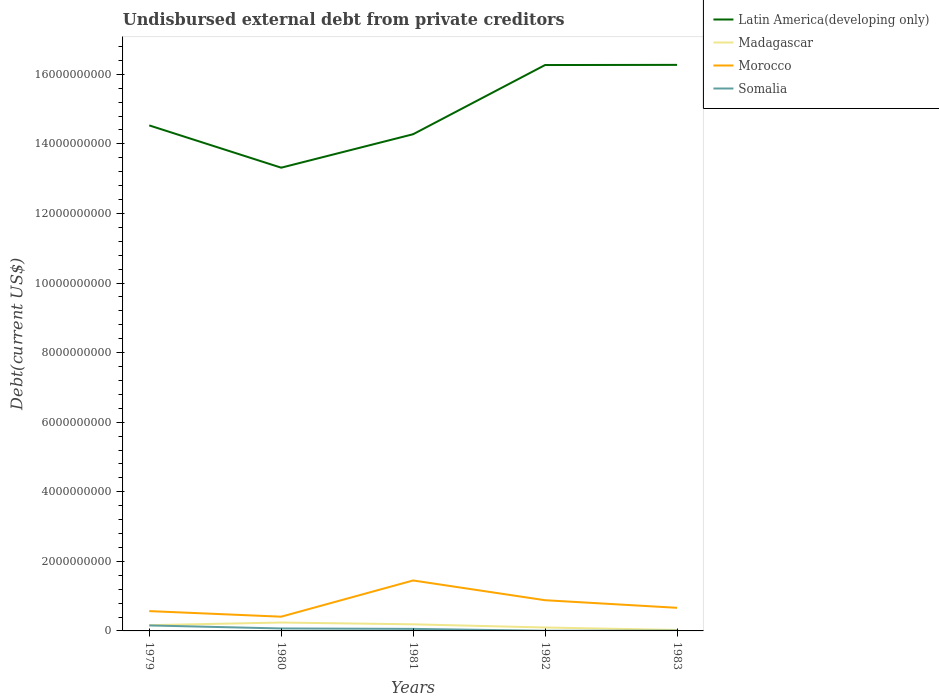Across all years, what is the maximum total debt in Somalia?
Keep it short and to the point. 5.57e+06. In which year was the total debt in Somalia maximum?
Make the answer very short. 1982. What is the total total debt in Latin America(developing only) in the graph?
Your response must be concise. -1.99e+09. What is the difference between the highest and the second highest total debt in Morocco?
Give a very brief answer. 1.04e+09. How many years are there in the graph?
Provide a short and direct response. 5. Are the values on the major ticks of Y-axis written in scientific E-notation?
Offer a very short reply. No. Does the graph contain grids?
Make the answer very short. No. Where does the legend appear in the graph?
Provide a short and direct response. Top right. How many legend labels are there?
Make the answer very short. 4. How are the legend labels stacked?
Your response must be concise. Vertical. What is the title of the graph?
Ensure brevity in your answer.  Undisbursed external debt from private creditors. What is the label or title of the Y-axis?
Provide a succinct answer. Debt(current US$). What is the Debt(current US$) of Latin America(developing only) in 1979?
Make the answer very short. 1.45e+1. What is the Debt(current US$) of Madagascar in 1979?
Offer a terse response. 1.65e+08. What is the Debt(current US$) of Morocco in 1979?
Your answer should be compact. 5.70e+08. What is the Debt(current US$) of Somalia in 1979?
Provide a succinct answer. 1.58e+08. What is the Debt(current US$) in Latin America(developing only) in 1980?
Provide a succinct answer. 1.33e+1. What is the Debt(current US$) of Madagascar in 1980?
Provide a short and direct response. 2.41e+08. What is the Debt(current US$) in Morocco in 1980?
Your response must be concise. 4.09e+08. What is the Debt(current US$) of Somalia in 1980?
Ensure brevity in your answer.  7.03e+07. What is the Debt(current US$) of Latin America(developing only) in 1981?
Ensure brevity in your answer.  1.43e+1. What is the Debt(current US$) in Madagascar in 1981?
Provide a short and direct response. 1.90e+08. What is the Debt(current US$) in Morocco in 1981?
Provide a short and direct response. 1.45e+09. What is the Debt(current US$) of Somalia in 1981?
Your response must be concise. 5.82e+07. What is the Debt(current US$) in Latin America(developing only) in 1982?
Keep it short and to the point. 1.63e+1. What is the Debt(current US$) of Madagascar in 1982?
Give a very brief answer. 9.86e+07. What is the Debt(current US$) of Morocco in 1982?
Your answer should be compact. 8.82e+08. What is the Debt(current US$) in Somalia in 1982?
Your answer should be compact. 5.57e+06. What is the Debt(current US$) in Latin America(developing only) in 1983?
Give a very brief answer. 1.63e+1. What is the Debt(current US$) in Madagascar in 1983?
Keep it short and to the point. 2.73e+07. What is the Debt(current US$) in Morocco in 1983?
Offer a very short reply. 6.64e+08. What is the Debt(current US$) of Somalia in 1983?
Keep it short and to the point. 8.74e+06. Across all years, what is the maximum Debt(current US$) in Latin America(developing only)?
Make the answer very short. 1.63e+1. Across all years, what is the maximum Debt(current US$) of Madagascar?
Make the answer very short. 2.41e+08. Across all years, what is the maximum Debt(current US$) in Morocco?
Provide a short and direct response. 1.45e+09. Across all years, what is the maximum Debt(current US$) in Somalia?
Give a very brief answer. 1.58e+08. Across all years, what is the minimum Debt(current US$) of Latin America(developing only)?
Keep it short and to the point. 1.33e+1. Across all years, what is the minimum Debt(current US$) in Madagascar?
Offer a very short reply. 2.73e+07. Across all years, what is the minimum Debt(current US$) in Morocco?
Your response must be concise. 4.09e+08. Across all years, what is the minimum Debt(current US$) in Somalia?
Your answer should be compact. 5.57e+06. What is the total Debt(current US$) in Latin America(developing only) in the graph?
Offer a very short reply. 7.47e+1. What is the total Debt(current US$) of Madagascar in the graph?
Your answer should be compact. 7.22e+08. What is the total Debt(current US$) in Morocco in the graph?
Ensure brevity in your answer.  3.98e+09. What is the total Debt(current US$) of Somalia in the graph?
Offer a terse response. 3.00e+08. What is the difference between the Debt(current US$) in Latin America(developing only) in 1979 and that in 1980?
Your answer should be very brief. 1.22e+09. What is the difference between the Debt(current US$) in Madagascar in 1979 and that in 1980?
Ensure brevity in your answer.  -7.65e+07. What is the difference between the Debt(current US$) of Morocco in 1979 and that in 1980?
Give a very brief answer. 1.60e+08. What is the difference between the Debt(current US$) of Somalia in 1979 and that in 1980?
Provide a short and direct response. 8.73e+07. What is the difference between the Debt(current US$) of Latin America(developing only) in 1979 and that in 1981?
Give a very brief answer. 2.53e+08. What is the difference between the Debt(current US$) in Madagascar in 1979 and that in 1981?
Your answer should be compact. -2.54e+07. What is the difference between the Debt(current US$) in Morocco in 1979 and that in 1981?
Ensure brevity in your answer.  -8.81e+08. What is the difference between the Debt(current US$) in Somalia in 1979 and that in 1981?
Keep it short and to the point. 9.94e+07. What is the difference between the Debt(current US$) of Latin America(developing only) in 1979 and that in 1982?
Provide a succinct answer. -1.74e+09. What is the difference between the Debt(current US$) in Madagascar in 1979 and that in 1982?
Your answer should be very brief. 6.61e+07. What is the difference between the Debt(current US$) of Morocco in 1979 and that in 1982?
Your answer should be compact. -3.13e+08. What is the difference between the Debt(current US$) in Somalia in 1979 and that in 1982?
Give a very brief answer. 1.52e+08. What is the difference between the Debt(current US$) of Latin America(developing only) in 1979 and that in 1983?
Your response must be concise. -1.74e+09. What is the difference between the Debt(current US$) of Madagascar in 1979 and that in 1983?
Your answer should be compact. 1.37e+08. What is the difference between the Debt(current US$) in Morocco in 1979 and that in 1983?
Your answer should be very brief. -9.48e+07. What is the difference between the Debt(current US$) in Somalia in 1979 and that in 1983?
Make the answer very short. 1.49e+08. What is the difference between the Debt(current US$) in Latin America(developing only) in 1980 and that in 1981?
Keep it short and to the point. -9.62e+08. What is the difference between the Debt(current US$) of Madagascar in 1980 and that in 1981?
Offer a very short reply. 5.11e+07. What is the difference between the Debt(current US$) of Morocco in 1980 and that in 1981?
Make the answer very short. -1.04e+09. What is the difference between the Debt(current US$) of Somalia in 1980 and that in 1981?
Your answer should be very brief. 1.21e+07. What is the difference between the Debt(current US$) in Latin America(developing only) in 1980 and that in 1982?
Provide a succinct answer. -2.95e+09. What is the difference between the Debt(current US$) of Madagascar in 1980 and that in 1982?
Your response must be concise. 1.43e+08. What is the difference between the Debt(current US$) in Morocco in 1980 and that in 1982?
Offer a terse response. -4.73e+08. What is the difference between the Debt(current US$) of Somalia in 1980 and that in 1982?
Your answer should be compact. 6.48e+07. What is the difference between the Debt(current US$) of Latin America(developing only) in 1980 and that in 1983?
Your answer should be compact. -2.96e+09. What is the difference between the Debt(current US$) in Madagascar in 1980 and that in 1983?
Give a very brief answer. 2.14e+08. What is the difference between the Debt(current US$) of Morocco in 1980 and that in 1983?
Offer a terse response. -2.55e+08. What is the difference between the Debt(current US$) in Somalia in 1980 and that in 1983?
Offer a terse response. 6.16e+07. What is the difference between the Debt(current US$) in Latin America(developing only) in 1981 and that in 1982?
Ensure brevity in your answer.  -1.99e+09. What is the difference between the Debt(current US$) in Madagascar in 1981 and that in 1982?
Your answer should be compact. 9.15e+07. What is the difference between the Debt(current US$) in Morocco in 1981 and that in 1982?
Keep it short and to the point. 5.68e+08. What is the difference between the Debt(current US$) of Somalia in 1981 and that in 1982?
Your response must be concise. 5.26e+07. What is the difference between the Debt(current US$) in Latin America(developing only) in 1981 and that in 1983?
Ensure brevity in your answer.  -1.99e+09. What is the difference between the Debt(current US$) in Madagascar in 1981 and that in 1983?
Offer a terse response. 1.63e+08. What is the difference between the Debt(current US$) of Morocco in 1981 and that in 1983?
Offer a very short reply. 7.86e+08. What is the difference between the Debt(current US$) in Somalia in 1981 and that in 1983?
Ensure brevity in your answer.  4.95e+07. What is the difference between the Debt(current US$) in Latin America(developing only) in 1982 and that in 1983?
Ensure brevity in your answer.  -4.65e+06. What is the difference between the Debt(current US$) in Madagascar in 1982 and that in 1983?
Offer a very short reply. 7.13e+07. What is the difference between the Debt(current US$) of Morocco in 1982 and that in 1983?
Your answer should be very brief. 2.18e+08. What is the difference between the Debt(current US$) of Somalia in 1982 and that in 1983?
Give a very brief answer. -3.17e+06. What is the difference between the Debt(current US$) of Latin America(developing only) in 1979 and the Debt(current US$) of Madagascar in 1980?
Your answer should be compact. 1.43e+1. What is the difference between the Debt(current US$) of Latin America(developing only) in 1979 and the Debt(current US$) of Morocco in 1980?
Provide a short and direct response. 1.41e+1. What is the difference between the Debt(current US$) of Latin America(developing only) in 1979 and the Debt(current US$) of Somalia in 1980?
Offer a terse response. 1.45e+1. What is the difference between the Debt(current US$) in Madagascar in 1979 and the Debt(current US$) in Morocco in 1980?
Provide a succinct answer. -2.45e+08. What is the difference between the Debt(current US$) in Madagascar in 1979 and the Debt(current US$) in Somalia in 1980?
Ensure brevity in your answer.  9.43e+07. What is the difference between the Debt(current US$) in Morocco in 1979 and the Debt(current US$) in Somalia in 1980?
Your answer should be compact. 4.99e+08. What is the difference between the Debt(current US$) in Latin America(developing only) in 1979 and the Debt(current US$) in Madagascar in 1981?
Ensure brevity in your answer.  1.43e+1. What is the difference between the Debt(current US$) of Latin America(developing only) in 1979 and the Debt(current US$) of Morocco in 1981?
Offer a very short reply. 1.31e+1. What is the difference between the Debt(current US$) in Latin America(developing only) in 1979 and the Debt(current US$) in Somalia in 1981?
Your answer should be very brief. 1.45e+1. What is the difference between the Debt(current US$) of Madagascar in 1979 and the Debt(current US$) of Morocco in 1981?
Give a very brief answer. -1.29e+09. What is the difference between the Debt(current US$) in Madagascar in 1979 and the Debt(current US$) in Somalia in 1981?
Your answer should be compact. 1.06e+08. What is the difference between the Debt(current US$) in Morocco in 1979 and the Debt(current US$) in Somalia in 1981?
Provide a short and direct response. 5.11e+08. What is the difference between the Debt(current US$) of Latin America(developing only) in 1979 and the Debt(current US$) of Madagascar in 1982?
Offer a terse response. 1.44e+1. What is the difference between the Debt(current US$) in Latin America(developing only) in 1979 and the Debt(current US$) in Morocco in 1982?
Keep it short and to the point. 1.36e+1. What is the difference between the Debt(current US$) of Latin America(developing only) in 1979 and the Debt(current US$) of Somalia in 1982?
Provide a short and direct response. 1.45e+1. What is the difference between the Debt(current US$) of Madagascar in 1979 and the Debt(current US$) of Morocco in 1982?
Your answer should be very brief. -7.18e+08. What is the difference between the Debt(current US$) of Madagascar in 1979 and the Debt(current US$) of Somalia in 1982?
Give a very brief answer. 1.59e+08. What is the difference between the Debt(current US$) in Morocco in 1979 and the Debt(current US$) in Somalia in 1982?
Your answer should be compact. 5.64e+08. What is the difference between the Debt(current US$) in Latin America(developing only) in 1979 and the Debt(current US$) in Madagascar in 1983?
Offer a terse response. 1.45e+1. What is the difference between the Debt(current US$) in Latin America(developing only) in 1979 and the Debt(current US$) in Morocco in 1983?
Make the answer very short. 1.39e+1. What is the difference between the Debt(current US$) in Latin America(developing only) in 1979 and the Debt(current US$) in Somalia in 1983?
Your response must be concise. 1.45e+1. What is the difference between the Debt(current US$) in Madagascar in 1979 and the Debt(current US$) in Morocco in 1983?
Offer a very short reply. -5.00e+08. What is the difference between the Debt(current US$) in Madagascar in 1979 and the Debt(current US$) in Somalia in 1983?
Your response must be concise. 1.56e+08. What is the difference between the Debt(current US$) of Morocco in 1979 and the Debt(current US$) of Somalia in 1983?
Your answer should be very brief. 5.61e+08. What is the difference between the Debt(current US$) of Latin America(developing only) in 1980 and the Debt(current US$) of Madagascar in 1981?
Offer a very short reply. 1.31e+1. What is the difference between the Debt(current US$) of Latin America(developing only) in 1980 and the Debt(current US$) of Morocco in 1981?
Keep it short and to the point. 1.19e+1. What is the difference between the Debt(current US$) of Latin America(developing only) in 1980 and the Debt(current US$) of Somalia in 1981?
Ensure brevity in your answer.  1.33e+1. What is the difference between the Debt(current US$) of Madagascar in 1980 and the Debt(current US$) of Morocco in 1981?
Your response must be concise. -1.21e+09. What is the difference between the Debt(current US$) of Madagascar in 1980 and the Debt(current US$) of Somalia in 1981?
Provide a succinct answer. 1.83e+08. What is the difference between the Debt(current US$) of Morocco in 1980 and the Debt(current US$) of Somalia in 1981?
Your answer should be compact. 3.51e+08. What is the difference between the Debt(current US$) in Latin America(developing only) in 1980 and the Debt(current US$) in Madagascar in 1982?
Make the answer very short. 1.32e+1. What is the difference between the Debt(current US$) in Latin America(developing only) in 1980 and the Debt(current US$) in Morocco in 1982?
Your response must be concise. 1.24e+1. What is the difference between the Debt(current US$) of Latin America(developing only) in 1980 and the Debt(current US$) of Somalia in 1982?
Offer a terse response. 1.33e+1. What is the difference between the Debt(current US$) in Madagascar in 1980 and the Debt(current US$) in Morocco in 1982?
Ensure brevity in your answer.  -6.41e+08. What is the difference between the Debt(current US$) of Madagascar in 1980 and the Debt(current US$) of Somalia in 1982?
Your answer should be very brief. 2.36e+08. What is the difference between the Debt(current US$) of Morocco in 1980 and the Debt(current US$) of Somalia in 1982?
Provide a short and direct response. 4.04e+08. What is the difference between the Debt(current US$) of Latin America(developing only) in 1980 and the Debt(current US$) of Madagascar in 1983?
Offer a very short reply. 1.33e+1. What is the difference between the Debt(current US$) of Latin America(developing only) in 1980 and the Debt(current US$) of Morocco in 1983?
Make the answer very short. 1.27e+1. What is the difference between the Debt(current US$) in Latin America(developing only) in 1980 and the Debt(current US$) in Somalia in 1983?
Offer a terse response. 1.33e+1. What is the difference between the Debt(current US$) in Madagascar in 1980 and the Debt(current US$) in Morocco in 1983?
Provide a succinct answer. -4.23e+08. What is the difference between the Debt(current US$) in Madagascar in 1980 and the Debt(current US$) in Somalia in 1983?
Give a very brief answer. 2.32e+08. What is the difference between the Debt(current US$) in Morocco in 1980 and the Debt(current US$) in Somalia in 1983?
Your answer should be compact. 4.01e+08. What is the difference between the Debt(current US$) in Latin America(developing only) in 1981 and the Debt(current US$) in Madagascar in 1982?
Offer a very short reply. 1.42e+1. What is the difference between the Debt(current US$) in Latin America(developing only) in 1981 and the Debt(current US$) in Morocco in 1982?
Your answer should be very brief. 1.34e+1. What is the difference between the Debt(current US$) in Latin America(developing only) in 1981 and the Debt(current US$) in Somalia in 1982?
Provide a short and direct response. 1.43e+1. What is the difference between the Debt(current US$) in Madagascar in 1981 and the Debt(current US$) in Morocco in 1982?
Offer a terse response. -6.92e+08. What is the difference between the Debt(current US$) of Madagascar in 1981 and the Debt(current US$) of Somalia in 1982?
Offer a terse response. 1.85e+08. What is the difference between the Debt(current US$) of Morocco in 1981 and the Debt(current US$) of Somalia in 1982?
Make the answer very short. 1.44e+09. What is the difference between the Debt(current US$) of Latin America(developing only) in 1981 and the Debt(current US$) of Madagascar in 1983?
Ensure brevity in your answer.  1.43e+1. What is the difference between the Debt(current US$) of Latin America(developing only) in 1981 and the Debt(current US$) of Morocco in 1983?
Provide a succinct answer. 1.36e+1. What is the difference between the Debt(current US$) in Latin America(developing only) in 1981 and the Debt(current US$) in Somalia in 1983?
Keep it short and to the point. 1.43e+1. What is the difference between the Debt(current US$) in Madagascar in 1981 and the Debt(current US$) in Morocco in 1983?
Provide a succinct answer. -4.74e+08. What is the difference between the Debt(current US$) of Madagascar in 1981 and the Debt(current US$) of Somalia in 1983?
Offer a very short reply. 1.81e+08. What is the difference between the Debt(current US$) of Morocco in 1981 and the Debt(current US$) of Somalia in 1983?
Your answer should be compact. 1.44e+09. What is the difference between the Debt(current US$) of Latin America(developing only) in 1982 and the Debt(current US$) of Madagascar in 1983?
Keep it short and to the point. 1.62e+1. What is the difference between the Debt(current US$) of Latin America(developing only) in 1982 and the Debt(current US$) of Morocco in 1983?
Offer a very short reply. 1.56e+1. What is the difference between the Debt(current US$) in Latin America(developing only) in 1982 and the Debt(current US$) in Somalia in 1983?
Your response must be concise. 1.63e+1. What is the difference between the Debt(current US$) of Madagascar in 1982 and the Debt(current US$) of Morocco in 1983?
Ensure brevity in your answer.  -5.66e+08. What is the difference between the Debt(current US$) in Madagascar in 1982 and the Debt(current US$) in Somalia in 1983?
Make the answer very short. 8.98e+07. What is the difference between the Debt(current US$) in Morocco in 1982 and the Debt(current US$) in Somalia in 1983?
Your response must be concise. 8.74e+08. What is the average Debt(current US$) of Latin America(developing only) per year?
Your response must be concise. 1.49e+1. What is the average Debt(current US$) in Madagascar per year?
Ensure brevity in your answer.  1.44e+08. What is the average Debt(current US$) of Morocco per year?
Your answer should be very brief. 7.95e+08. What is the average Debt(current US$) of Somalia per year?
Provide a succinct answer. 6.01e+07. In the year 1979, what is the difference between the Debt(current US$) in Latin America(developing only) and Debt(current US$) in Madagascar?
Your answer should be very brief. 1.44e+1. In the year 1979, what is the difference between the Debt(current US$) in Latin America(developing only) and Debt(current US$) in Morocco?
Give a very brief answer. 1.40e+1. In the year 1979, what is the difference between the Debt(current US$) in Latin America(developing only) and Debt(current US$) in Somalia?
Keep it short and to the point. 1.44e+1. In the year 1979, what is the difference between the Debt(current US$) in Madagascar and Debt(current US$) in Morocco?
Provide a succinct answer. -4.05e+08. In the year 1979, what is the difference between the Debt(current US$) in Madagascar and Debt(current US$) in Somalia?
Ensure brevity in your answer.  7.07e+06. In the year 1979, what is the difference between the Debt(current US$) in Morocco and Debt(current US$) in Somalia?
Ensure brevity in your answer.  4.12e+08. In the year 1980, what is the difference between the Debt(current US$) of Latin America(developing only) and Debt(current US$) of Madagascar?
Your answer should be very brief. 1.31e+1. In the year 1980, what is the difference between the Debt(current US$) of Latin America(developing only) and Debt(current US$) of Morocco?
Your answer should be compact. 1.29e+1. In the year 1980, what is the difference between the Debt(current US$) in Latin America(developing only) and Debt(current US$) in Somalia?
Ensure brevity in your answer.  1.32e+1. In the year 1980, what is the difference between the Debt(current US$) of Madagascar and Debt(current US$) of Morocco?
Give a very brief answer. -1.68e+08. In the year 1980, what is the difference between the Debt(current US$) of Madagascar and Debt(current US$) of Somalia?
Your response must be concise. 1.71e+08. In the year 1980, what is the difference between the Debt(current US$) of Morocco and Debt(current US$) of Somalia?
Ensure brevity in your answer.  3.39e+08. In the year 1981, what is the difference between the Debt(current US$) of Latin America(developing only) and Debt(current US$) of Madagascar?
Make the answer very short. 1.41e+1. In the year 1981, what is the difference between the Debt(current US$) of Latin America(developing only) and Debt(current US$) of Morocco?
Offer a terse response. 1.28e+1. In the year 1981, what is the difference between the Debt(current US$) in Latin America(developing only) and Debt(current US$) in Somalia?
Offer a very short reply. 1.42e+1. In the year 1981, what is the difference between the Debt(current US$) of Madagascar and Debt(current US$) of Morocco?
Your response must be concise. -1.26e+09. In the year 1981, what is the difference between the Debt(current US$) of Madagascar and Debt(current US$) of Somalia?
Ensure brevity in your answer.  1.32e+08. In the year 1981, what is the difference between the Debt(current US$) in Morocco and Debt(current US$) in Somalia?
Provide a short and direct response. 1.39e+09. In the year 1982, what is the difference between the Debt(current US$) of Latin America(developing only) and Debt(current US$) of Madagascar?
Your answer should be very brief. 1.62e+1. In the year 1982, what is the difference between the Debt(current US$) of Latin America(developing only) and Debt(current US$) of Morocco?
Offer a terse response. 1.54e+1. In the year 1982, what is the difference between the Debt(current US$) of Latin America(developing only) and Debt(current US$) of Somalia?
Your response must be concise. 1.63e+1. In the year 1982, what is the difference between the Debt(current US$) of Madagascar and Debt(current US$) of Morocco?
Make the answer very short. -7.84e+08. In the year 1982, what is the difference between the Debt(current US$) of Madagascar and Debt(current US$) of Somalia?
Offer a very short reply. 9.30e+07. In the year 1982, what is the difference between the Debt(current US$) of Morocco and Debt(current US$) of Somalia?
Your answer should be very brief. 8.77e+08. In the year 1983, what is the difference between the Debt(current US$) of Latin America(developing only) and Debt(current US$) of Madagascar?
Your response must be concise. 1.62e+1. In the year 1983, what is the difference between the Debt(current US$) in Latin America(developing only) and Debt(current US$) in Morocco?
Provide a short and direct response. 1.56e+1. In the year 1983, what is the difference between the Debt(current US$) of Latin America(developing only) and Debt(current US$) of Somalia?
Offer a very short reply. 1.63e+1. In the year 1983, what is the difference between the Debt(current US$) in Madagascar and Debt(current US$) in Morocco?
Keep it short and to the point. -6.37e+08. In the year 1983, what is the difference between the Debt(current US$) of Madagascar and Debt(current US$) of Somalia?
Your response must be concise. 1.85e+07. In the year 1983, what is the difference between the Debt(current US$) of Morocco and Debt(current US$) of Somalia?
Provide a succinct answer. 6.56e+08. What is the ratio of the Debt(current US$) in Latin America(developing only) in 1979 to that in 1980?
Give a very brief answer. 1.09. What is the ratio of the Debt(current US$) in Madagascar in 1979 to that in 1980?
Your answer should be very brief. 0.68. What is the ratio of the Debt(current US$) of Morocco in 1979 to that in 1980?
Make the answer very short. 1.39. What is the ratio of the Debt(current US$) in Somalia in 1979 to that in 1980?
Your response must be concise. 2.24. What is the ratio of the Debt(current US$) of Latin America(developing only) in 1979 to that in 1981?
Your answer should be very brief. 1.02. What is the ratio of the Debt(current US$) of Madagascar in 1979 to that in 1981?
Offer a terse response. 0.87. What is the ratio of the Debt(current US$) of Morocco in 1979 to that in 1981?
Ensure brevity in your answer.  0.39. What is the ratio of the Debt(current US$) in Somalia in 1979 to that in 1981?
Give a very brief answer. 2.71. What is the ratio of the Debt(current US$) in Latin America(developing only) in 1979 to that in 1982?
Provide a succinct answer. 0.89. What is the ratio of the Debt(current US$) in Madagascar in 1979 to that in 1982?
Give a very brief answer. 1.67. What is the ratio of the Debt(current US$) in Morocco in 1979 to that in 1982?
Provide a succinct answer. 0.65. What is the ratio of the Debt(current US$) in Somalia in 1979 to that in 1982?
Your answer should be very brief. 28.31. What is the ratio of the Debt(current US$) in Latin America(developing only) in 1979 to that in 1983?
Offer a very short reply. 0.89. What is the ratio of the Debt(current US$) of Madagascar in 1979 to that in 1983?
Ensure brevity in your answer.  6.04. What is the ratio of the Debt(current US$) in Morocco in 1979 to that in 1983?
Offer a terse response. 0.86. What is the ratio of the Debt(current US$) in Somalia in 1979 to that in 1983?
Your answer should be very brief. 18.03. What is the ratio of the Debt(current US$) of Latin America(developing only) in 1980 to that in 1981?
Make the answer very short. 0.93. What is the ratio of the Debt(current US$) of Madagascar in 1980 to that in 1981?
Your response must be concise. 1.27. What is the ratio of the Debt(current US$) in Morocco in 1980 to that in 1981?
Your answer should be compact. 0.28. What is the ratio of the Debt(current US$) in Somalia in 1980 to that in 1981?
Keep it short and to the point. 1.21. What is the ratio of the Debt(current US$) in Latin America(developing only) in 1980 to that in 1982?
Offer a terse response. 0.82. What is the ratio of the Debt(current US$) in Madagascar in 1980 to that in 1982?
Offer a terse response. 2.45. What is the ratio of the Debt(current US$) of Morocco in 1980 to that in 1982?
Offer a terse response. 0.46. What is the ratio of the Debt(current US$) of Somalia in 1980 to that in 1982?
Your answer should be very brief. 12.63. What is the ratio of the Debt(current US$) in Latin America(developing only) in 1980 to that in 1983?
Your answer should be compact. 0.82. What is the ratio of the Debt(current US$) of Madagascar in 1980 to that in 1983?
Give a very brief answer. 8.84. What is the ratio of the Debt(current US$) in Morocco in 1980 to that in 1983?
Offer a terse response. 0.62. What is the ratio of the Debt(current US$) of Somalia in 1980 to that in 1983?
Provide a short and direct response. 8.05. What is the ratio of the Debt(current US$) of Latin America(developing only) in 1981 to that in 1982?
Give a very brief answer. 0.88. What is the ratio of the Debt(current US$) in Madagascar in 1981 to that in 1982?
Ensure brevity in your answer.  1.93. What is the ratio of the Debt(current US$) in Morocco in 1981 to that in 1982?
Your response must be concise. 1.64. What is the ratio of the Debt(current US$) of Somalia in 1981 to that in 1982?
Keep it short and to the point. 10.45. What is the ratio of the Debt(current US$) in Latin America(developing only) in 1981 to that in 1983?
Ensure brevity in your answer.  0.88. What is the ratio of the Debt(current US$) in Madagascar in 1981 to that in 1983?
Make the answer very short. 6.97. What is the ratio of the Debt(current US$) of Morocco in 1981 to that in 1983?
Offer a very short reply. 2.18. What is the ratio of the Debt(current US$) of Somalia in 1981 to that in 1983?
Ensure brevity in your answer.  6.66. What is the ratio of the Debt(current US$) of Latin America(developing only) in 1982 to that in 1983?
Your answer should be compact. 1. What is the ratio of the Debt(current US$) in Madagascar in 1982 to that in 1983?
Provide a short and direct response. 3.61. What is the ratio of the Debt(current US$) in Morocco in 1982 to that in 1983?
Ensure brevity in your answer.  1.33. What is the ratio of the Debt(current US$) in Somalia in 1982 to that in 1983?
Your answer should be compact. 0.64. What is the difference between the highest and the second highest Debt(current US$) of Latin America(developing only)?
Give a very brief answer. 4.65e+06. What is the difference between the highest and the second highest Debt(current US$) in Madagascar?
Offer a very short reply. 5.11e+07. What is the difference between the highest and the second highest Debt(current US$) of Morocco?
Provide a succinct answer. 5.68e+08. What is the difference between the highest and the second highest Debt(current US$) in Somalia?
Provide a short and direct response. 8.73e+07. What is the difference between the highest and the lowest Debt(current US$) in Latin America(developing only)?
Provide a short and direct response. 2.96e+09. What is the difference between the highest and the lowest Debt(current US$) in Madagascar?
Give a very brief answer. 2.14e+08. What is the difference between the highest and the lowest Debt(current US$) in Morocco?
Your answer should be compact. 1.04e+09. What is the difference between the highest and the lowest Debt(current US$) of Somalia?
Give a very brief answer. 1.52e+08. 